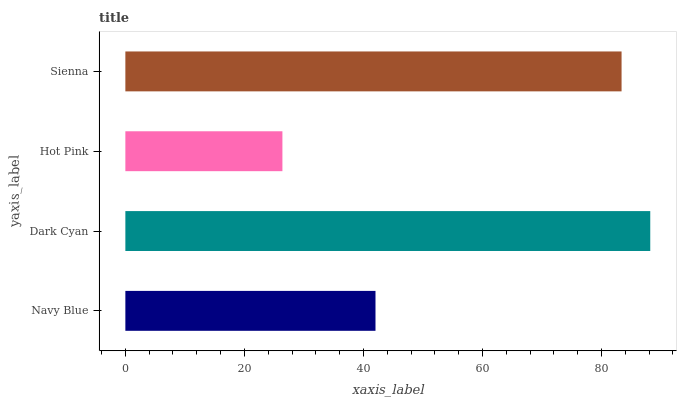Is Hot Pink the minimum?
Answer yes or no. Yes. Is Dark Cyan the maximum?
Answer yes or no. Yes. Is Dark Cyan the minimum?
Answer yes or no. No. Is Hot Pink the maximum?
Answer yes or no. No. Is Dark Cyan greater than Hot Pink?
Answer yes or no. Yes. Is Hot Pink less than Dark Cyan?
Answer yes or no. Yes. Is Hot Pink greater than Dark Cyan?
Answer yes or no. No. Is Dark Cyan less than Hot Pink?
Answer yes or no. No. Is Sienna the high median?
Answer yes or no. Yes. Is Navy Blue the low median?
Answer yes or no. Yes. Is Navy Blue the high median?
Answer yes or no. No. Is Sienna the low median?
Answer yes or no. No. 